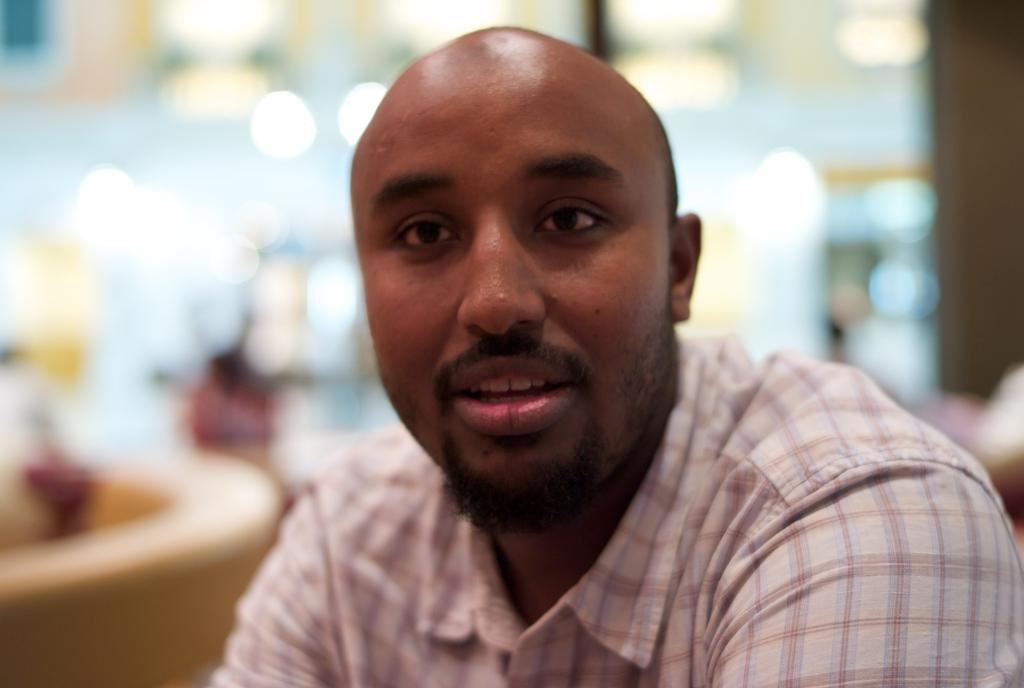What is present in the image? There is a man in the image. Can you describe the background of the image? The background of the image is blurry. What type of laborer is the man in the image? There is no indication in the image that the man is a laborer, so it cannot be determined from the picture. Is there a seat visible in the image? There is no seat present in the image. Can you see any letters or words in the image? There is no mention of letters or words in the image, so it cannot be determined if any are present. 